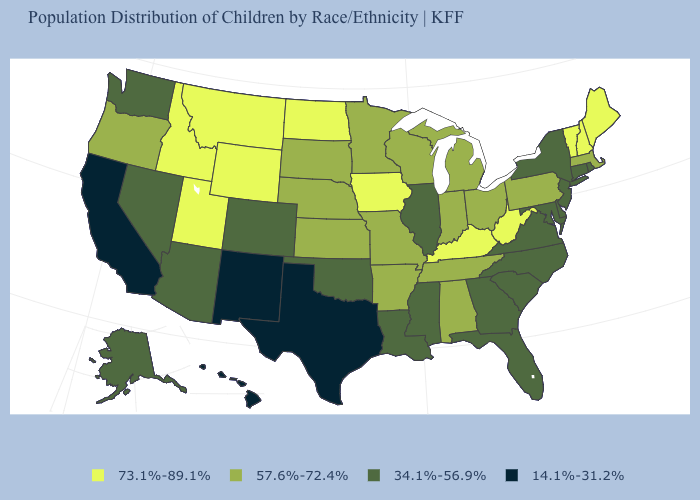What is the value of Connecticut?
Quick response, please. 34.1%-56.9%. Does Illinois have the lowest value in the MidWest?
Quick response, please. Yes. Name the states that have a value in the range 34.1%-56.9%?
Keep it brief. Alaska, Arizona, Colorado, Connecticut, Delaware, Florida, Georgia, Illinois, Louisiana, Maryland, Mississippi, Nevada, New Jersey, New York, North Carolina, Oklahoma, Rhode Island, South Carolina, Virginia, Washington. What is the value of Iowa?
Answer briefly. 73.1%-89.1%. What is the value of Utah?
Short answer required. 73.1%-89.1%. Name the states that have a value in the range 57.6%-72.4%?
Be succinct. Alabama, Arkansas, Indiana, Kansas, Massachusetts, Michigan, Minnesota, Missouri, Nebraska, Ohio, Oregon, Pennsylvania, South Dakota, Tennessee, Wisconsin. Name the states that have a value in the range 73.1%-89.1%?
Quick response, please. Idaho, Iowa, Kentucky, Maine, Montana, New Hampshire, North Dakota, Utah, Vermont, West Virginia, Wyoming. What is the value of New York?
Give a very brief answer. 34.1%-56.9%. Among the states that border Pennsylvania , does New York have the lowest value?
Answer briefly. Yes. Does Utah have the highest value in the USA?
Answer briefly. Yes. What is the highest value in the USA?
Give a very brief answer. 73.1%-89.1%. Among the states that border North Dakota , which have the lowest value?
Short answer required. Minnesota, South Dakota. Which states have the lowest value in the South?
Answer briefly. Texas. What is the value of Rhode Island?
Short answer required. 34.1%-56.9%. 